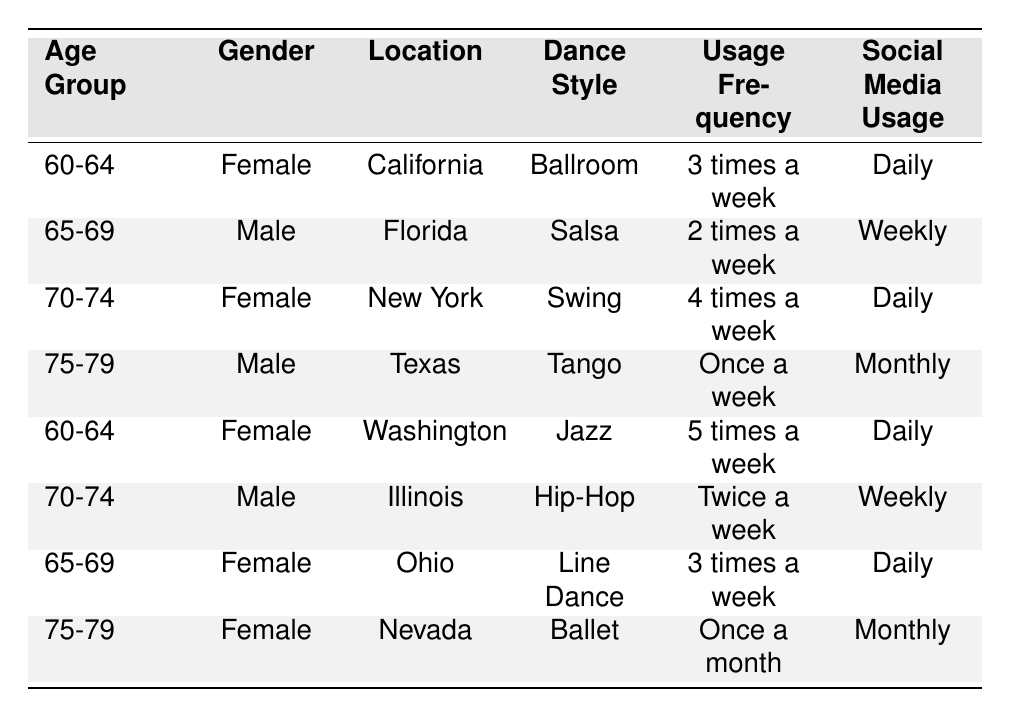What is the most popular dance style among users aged 70-74? There are two entries for the age group 70-74: one is "Swing" for a female in New York and the other is "Hip-Hop" for a male in Illinois. Both options are present, but we cannot definitively say one is more popular than the other based solely on this data.
Answer: Both "Swing" and "Hip-Hop" are popular How many users have a usage frequency of "Once a week"? There are two entries with a usage frequency of "Once a week": one male aged 75-79 in Texas who dances Tango and one female aged 75-79 in Nevada who dances Ballet.
Answer: 2 users Which location has the highest frequency of social media usage? Among the users, California, New York, and Ohio have daily social media usage, while Florida and Illinois have weekly usage, and Texas and Nevada have monthly. Therefore, California, New York, and Ohio lead in social media usage frequency.
Answer: California, New York, and Ohio What percentage of users aged 60-64 are female? There are two users in the 60-64 age group, both of whom are female, so 100% of the users in this age group are female. To find the percentage, divide the number of females by the total number and then multiply by 100: (2/2) * 100 = 100%.
Answer: 100% Is it true that all users dance more than once a week? Not all users dance more than once a week. The male aged 75-79 dances once a week and the female aged 75-79 dances once a month. Therefore, it is not true that all users have a frequency of more than once a week.
Answer: No What is the average usage frequency for all users? First, we assign values to usage frequency: Once a month = 1, Once a week = 1, Twice a week = 2, 2 times a week = 2, 3 times a week = 3, 4 times a week = 4, and 5 times a week = 5. The usage frequencies are: 3, 2, 4, 1, 5, 2, 3, 1. We sum these to get 21 and divide by 8 (total users) to find the average: 21/8 = 2.625, which can be rounded to approximately 2.6 times a week.
Answer: Approximately 2.6 times a week Which dance style is associated with the highest usage frequency? The highest usage frequency is 5 times a week, associated with the female user from Washington who dances Jazz.
Answer: Jazz How many users use social media daily? There are four users who use social media daily: one aged 60-64 in California (Ballroom), one aged 70-74 in New York (Swing), and one aged 65-69 in Ohio (Line Dance) with the last user being from Washington (Jazz). Therefore, there are four users who use social media daily.
Answer: 4 users How does the usage frequency of males aged 75-79 compare to females in the same age group? There is one male aged 75-79 who dances once a week and one female aged 75-79 who dances once a month. The male has a higher usage frequency compared to the female.
Answer: The male has a higher frequency 